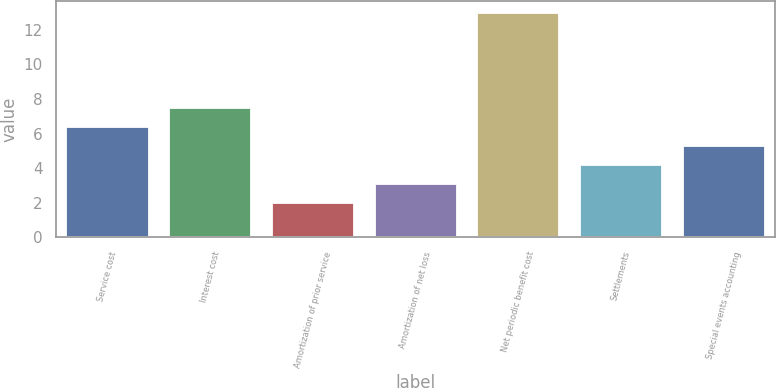Convert chart. <chart><loc_0><loc_0><loc_500><loc_500><bar_chart><fcel>Service cost<fcel>Interest cost<fcel>Amortization of prior service<fcel>Amortization of net loss<fcel>Net periodic benefit cost<fcel>Settlements<fcel>Special events accounting<nl><fcel>6.4<fcel>7.5<fcel>2<fcel>3.1<fcel>13<fcel>4.2<fcel>5.3<nl></chart> 